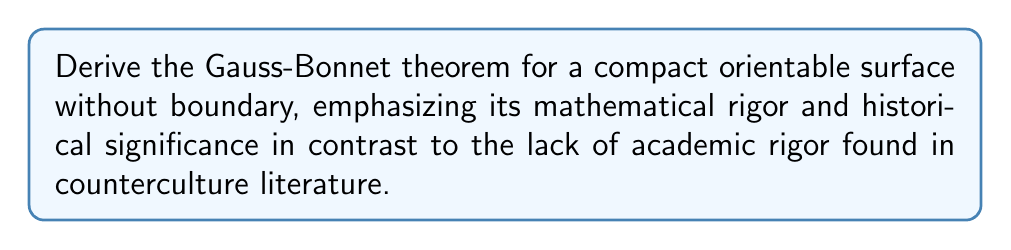Could you help me with this problem? Let's derive the Gauss-Bonnet theorem with the utmost mathematical rigor:

1) Consider a compact orientable surface $S$ without boundary.

2) Triangulate the surface into a finite number of triangles $\{T_i\}$.

3) For each triangle $T_i$, let $\alpha_i$, $\beta_i$, and $\gamma_i$ be its interior angles.

4) The sum of the interior angles of a geodesic triangle on a curved surface is:

   $$\alpha_i + \beta_i + \gamma_i = \pi + \int_{T_i} K dA$$

   where $K$ is the Gaussian curvature and $dA$ is the area element.

5) Sum this equation over all triangles:

   $$\sum_i (\alpha_i + \beta_i + \gamma_i) = N\pi + \int_S K dA$$

   where $N$ is the number of triangles.

6) The left-hand side equals $2\pi V$, where $V$ is the number of vertices in the triangulation, because each vertex contributes $2\pi$ to the sum.

7) Therefore:

   $$2\pi V = N\pi + \int_S K dA$$

8) The Euler characteristic of the surface is $\chi(S) = V - E + F$, where $E$ is the number of edges and $F = N$ is the number of faces.

9) For a triangulation, we have the relation $3F = 2E$ (each edge is shared by two triangles, and each triangle has three edges).

10) Substitute this into the Euler characteristic:

    $$\chi(S) = V - \frac{3}{2}F + F = V - \frac{1}{2}F = V - \frac{1}{2}N$$

11) Rearrange the equation from step 7:

    $$2\pi(V - \frac{1}{2}N) = \int_S K dA$$

12) The left-hand side is $2\pi\chi(S)$, giving us the Gauss-Bonnet theorem:

    $$\int_S K dA = 2\pi\chi(S)$$

This rigorous derivation, rooted in centuries of mathematical tradition, stands in stark contrast to the often whimsical and unstructured nature of counterculture literature.
Answer: $$\int_S K dA = 2\pi\chi(S)$$ 